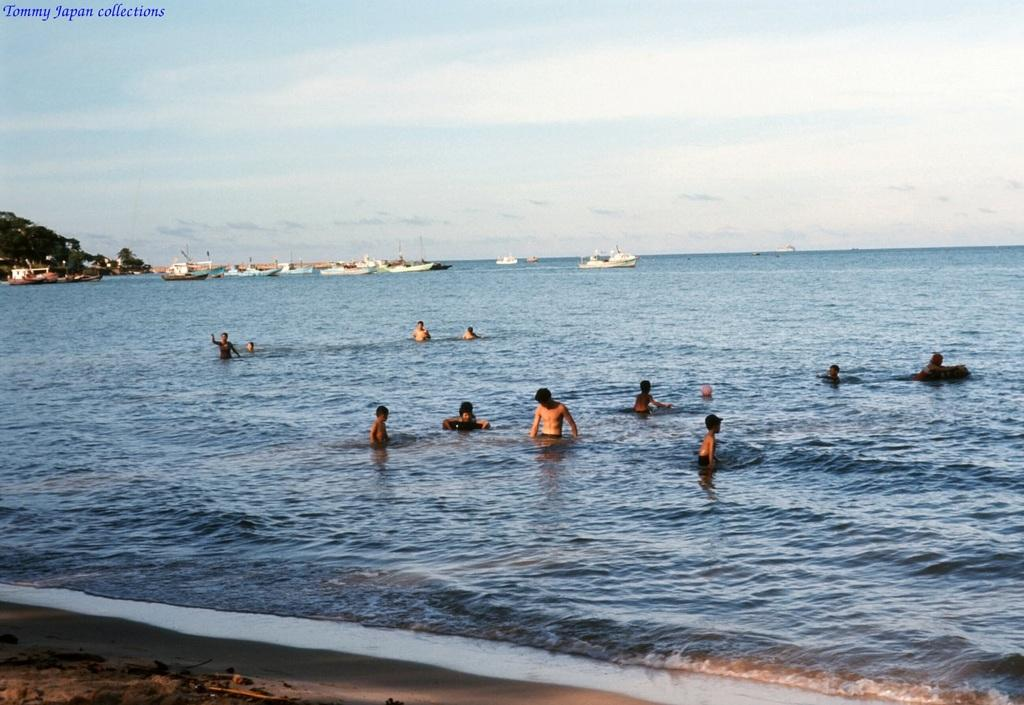What is the primary element in the image? There is water in the image. What are the people in the image doing? The people are in the water. What else can be seen in the water besides people? There are boats in the water. What can be seen in the background of the image? The sky is visible in the background of the image. Is there any additional information about the image? Yes, there is a watermark in the image. Can you tell me how many fowl are perched on the church in the image? There is no church or fowl present in the image; it features water, people, boats, and the sky. 